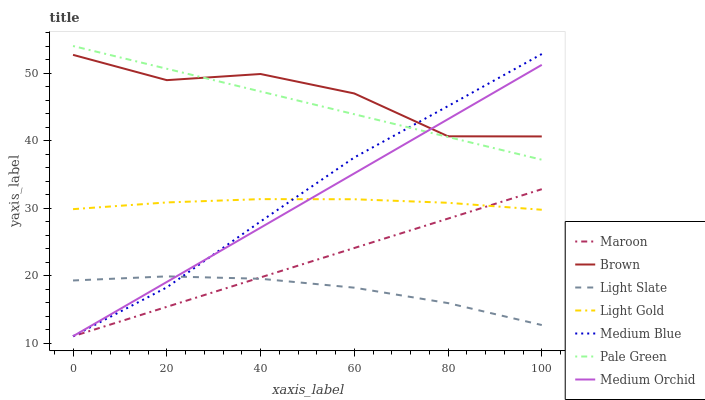Does Medium Orchid have the minimum area under the curve?
Answer yes or no. No. Does Medium Orchid have the maximum area under the curve?
Answer yes or no. No. Is Light Slate the smoothest?
Answer yes or no. No. Is Light Slate the roughest?
Answer yes or no. No. Does Light Slate have the lowest value?
Answer yes or no. No. Does Medium Orchid have the highest value?
Answer yes or no. No. Is Maroon less than Brown?
Answer yes or no. Yes. Is Brown greater than Light Gold?
Answer yes or no. Yes. Does Maroon intersect Brown?
Answer yes or no. No. 